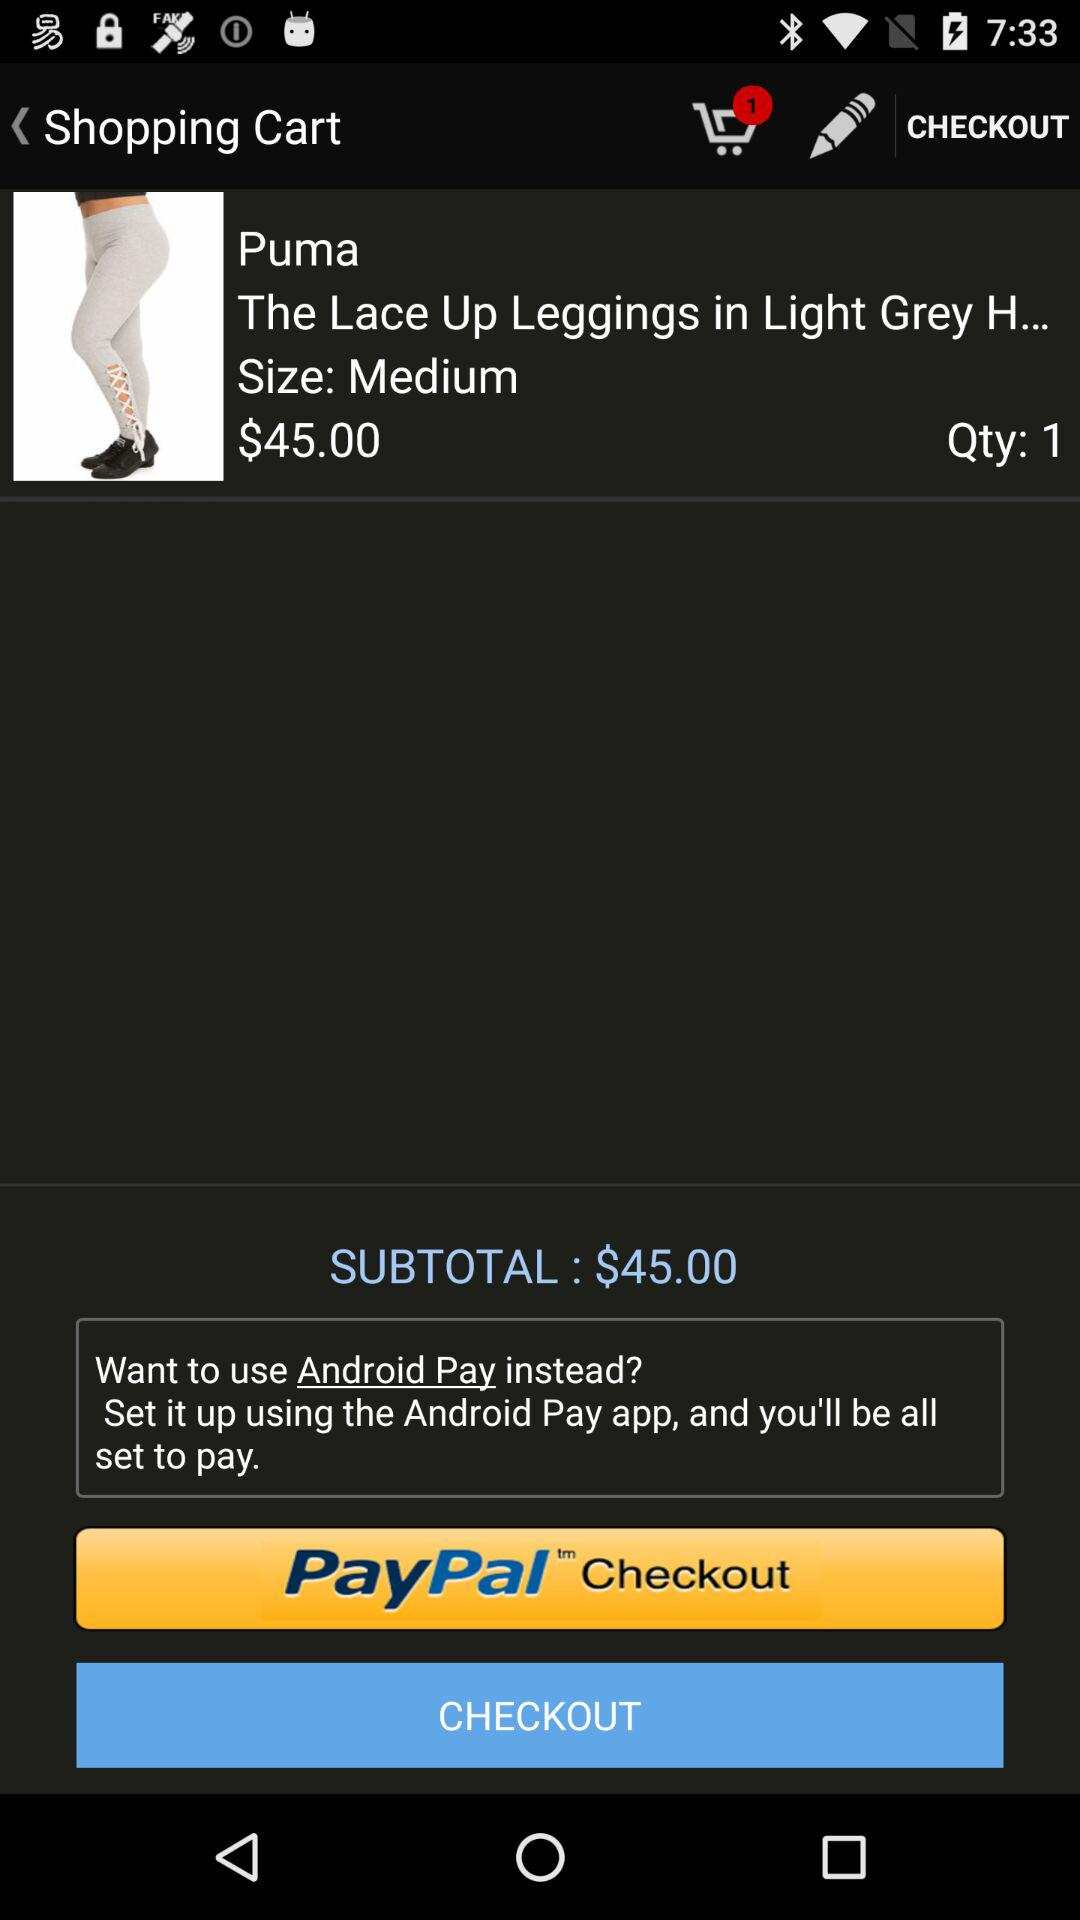What is the number of items in the shopping cart? There is 1 item in the shopping cart. 